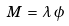<formula> <loc_0><loc_0><loc_500><loc_500>M \, = \, \lambda \, \phi</formula> 